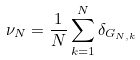<formula> <loc_0><loc_0><loc_500><loc_500>\nu _ { N } = \frac { 1 } { N } \sum _ { k = 1 } ^ { N } \delta _ { G _ { N , k } }</formula> 